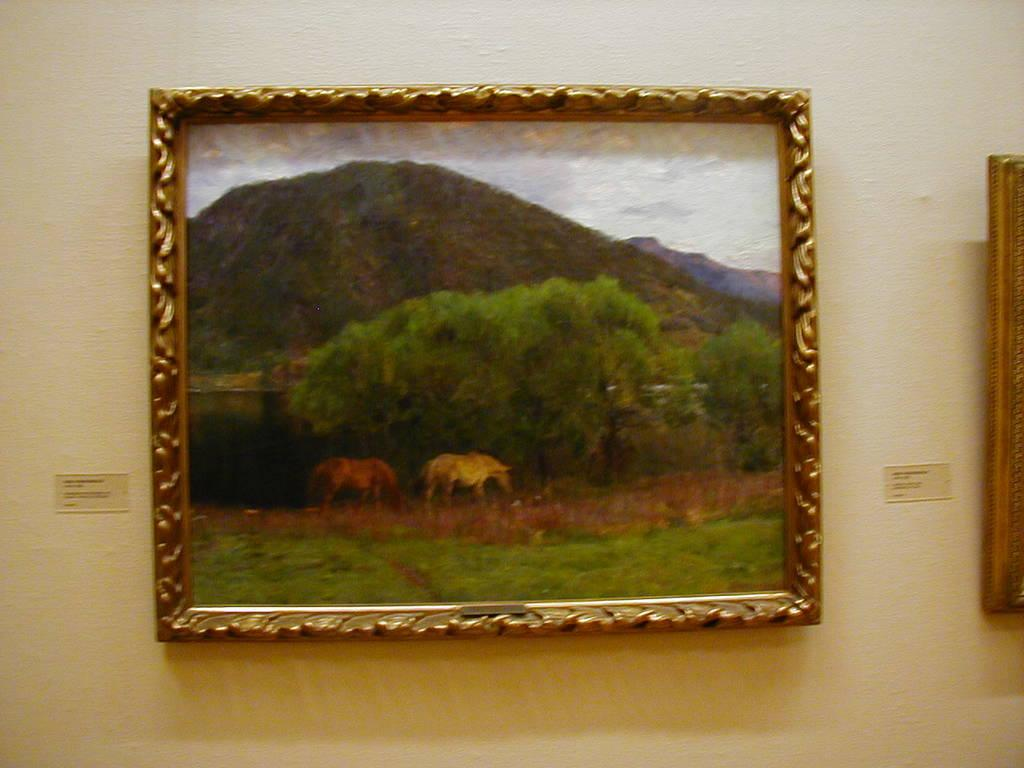What can be seen on the wall in the image? There are photo frames on the wall in the image. How many photo frames are visible on the wall? The number of photo frames cannot be determined from the provided fact. What might be displayed in the photo frames? The contents of the photo frames cannot be determined from the provided fact. What type of guitar is being played by the person in the image? There is no person or guitar present in the image; it only features photo frames on the wall. 